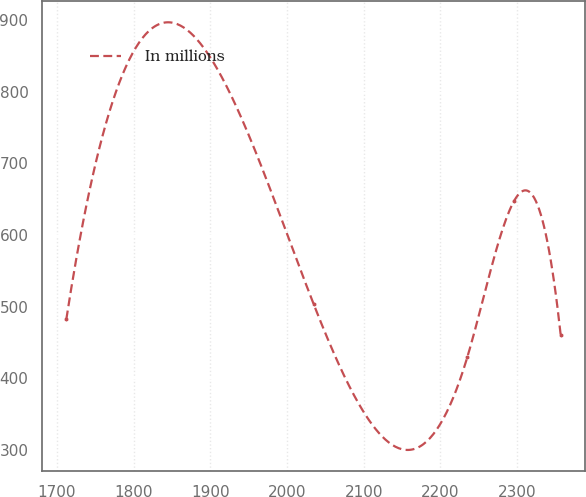Convert chart to OTSL. <chart><loc_0><loc_0><loc_500><loc_500><line_chart><ecel><fcel>In millions<nl><fcel>1712.44<fcel>482.09<nl><fcel>2034.55<fcel>503.88<nl><fcel>2235.01<fcel>429.45<nl><fcel>2295.82<fcel>647.37<nl><fcel>2356.63<fcel>460.3<nl></chart> 